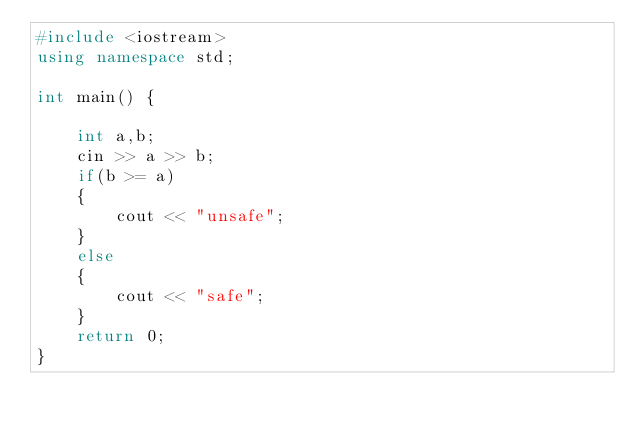<code> <loc_0><loc_0><loc_500><loc_500><_C++_>#include <iostream>
using namespace std;

int main() {
	
	int a,b;
	cin >> a >> b;
	if(b >= a)
	{
	    cout << "unsafe";
	}
	else
	{
	    cout << "safe";
	}
	return 0;
}
</code> 